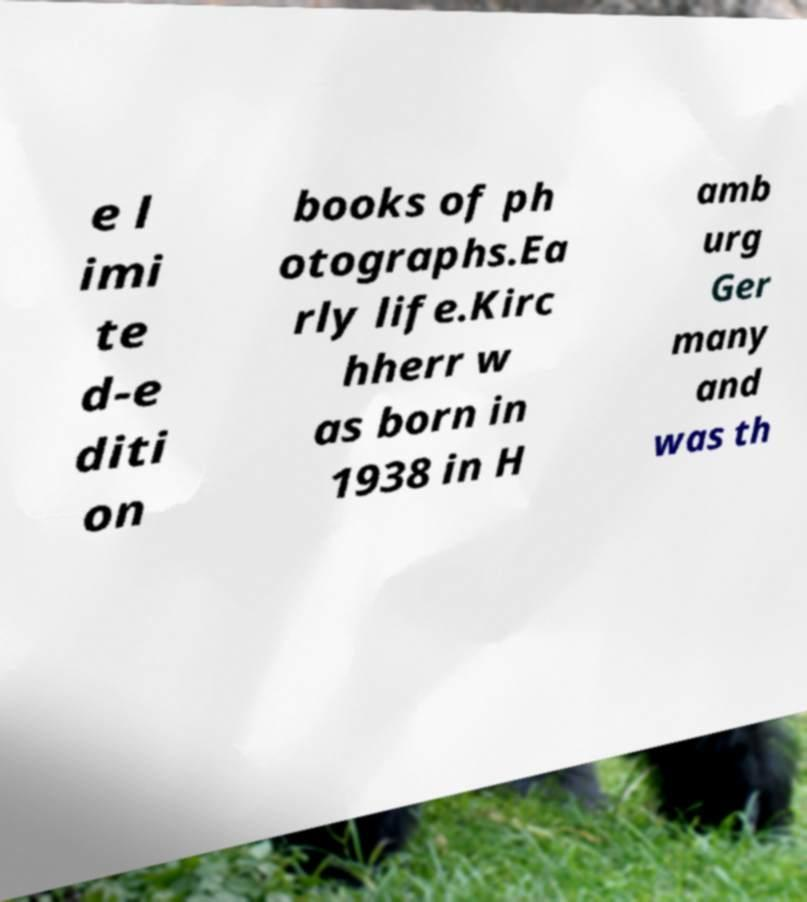Can you read and provide the text displayed in the image?This photo seems to have some interesting text. Can you extract and type it out for me? e l imi te d-e diti on books of ph otographs.Ea rly life.Kirc hherr w as born in 1938 in H amb urg Ger many and was th 